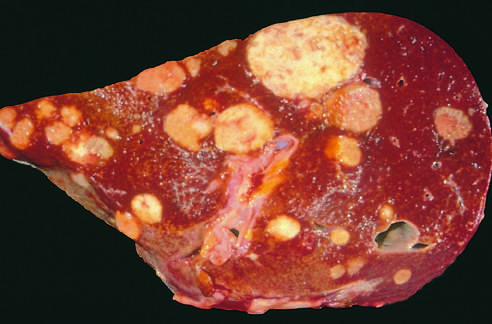s a liver studded with metastatic cancer?
Answer the question using a single word or phrase. Yes 